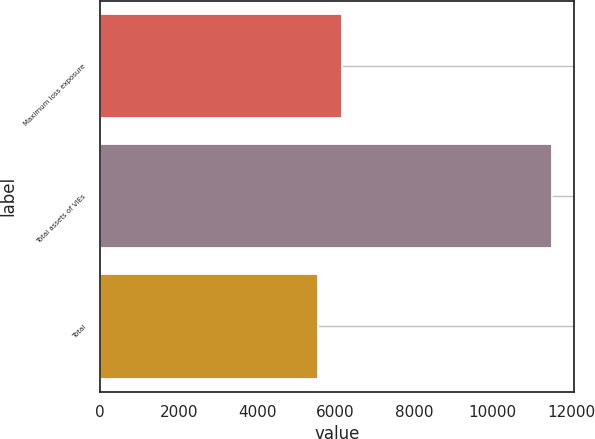Convert chart to OTSL. <chart><loc_0><loc_0><loc_500><loc_500><bar_chart><fcel>Maximum loss exposure<fcel>Total assets of VIEs<fcel>Total<nl><fcel>6158.3<fcel>11507<fcel>5564<nl></chart> 